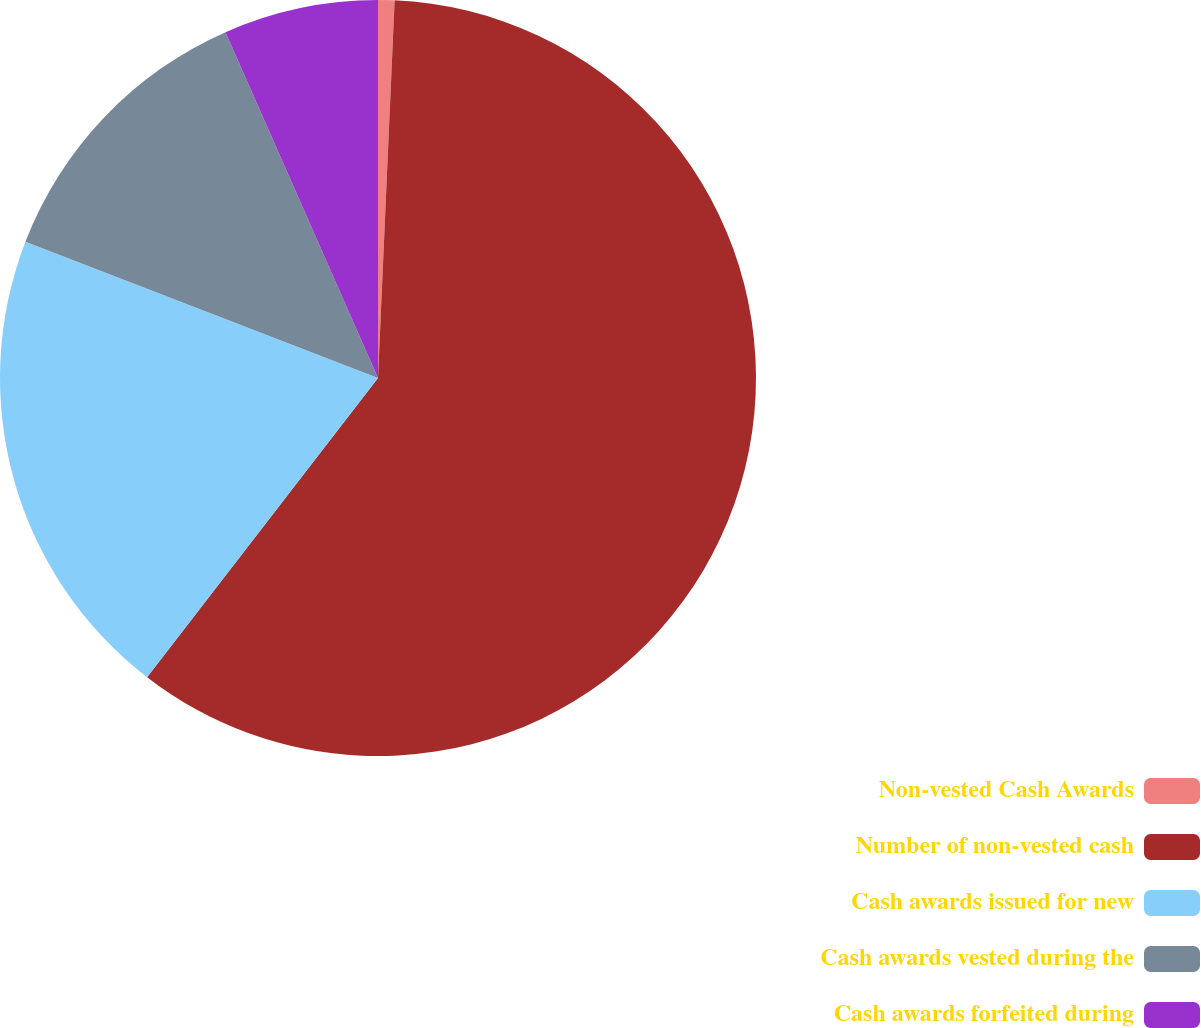Convert chart to OTSL. <chart><loc_0><loc_0><loc_500><loc_500><pie_chart><fcel>Non-vested Cash Awards<fcel>Number of non-vested cash<fcel>Cash awards issued for new<fcel>Cash awards vested during the<fcel>Cash awards forfeited during<nl><fcel>0.7%<fcel>59.76%<fcel>20.41%<fcel>12.52%<fcel>6.61%<nl></chart> 